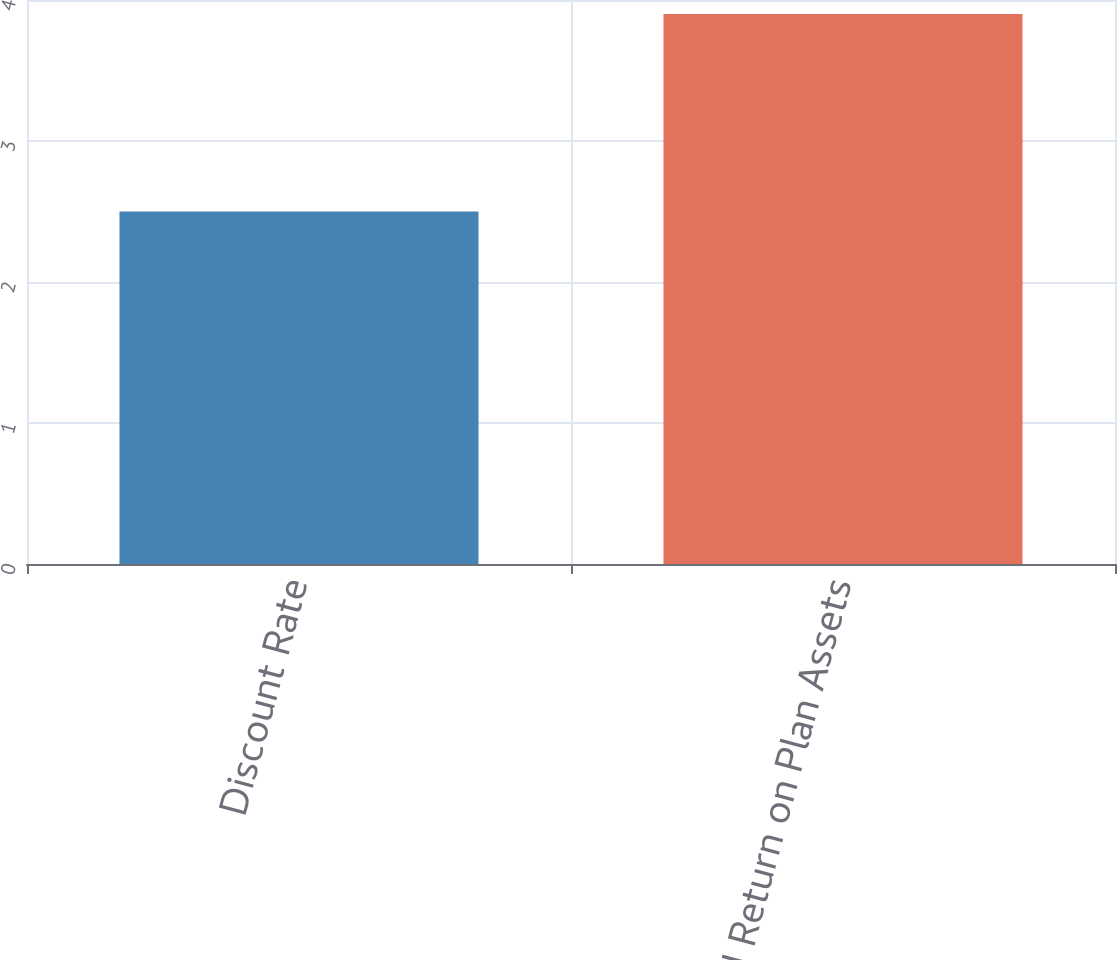<chart> <loc_0><loc_0><loc_500><loc_500><bar_chart><fcel>Discount Rate<fcel>Expected Return on Plan Assets<nl><fcel>2.5<fcel>3.9<nl></chart> 